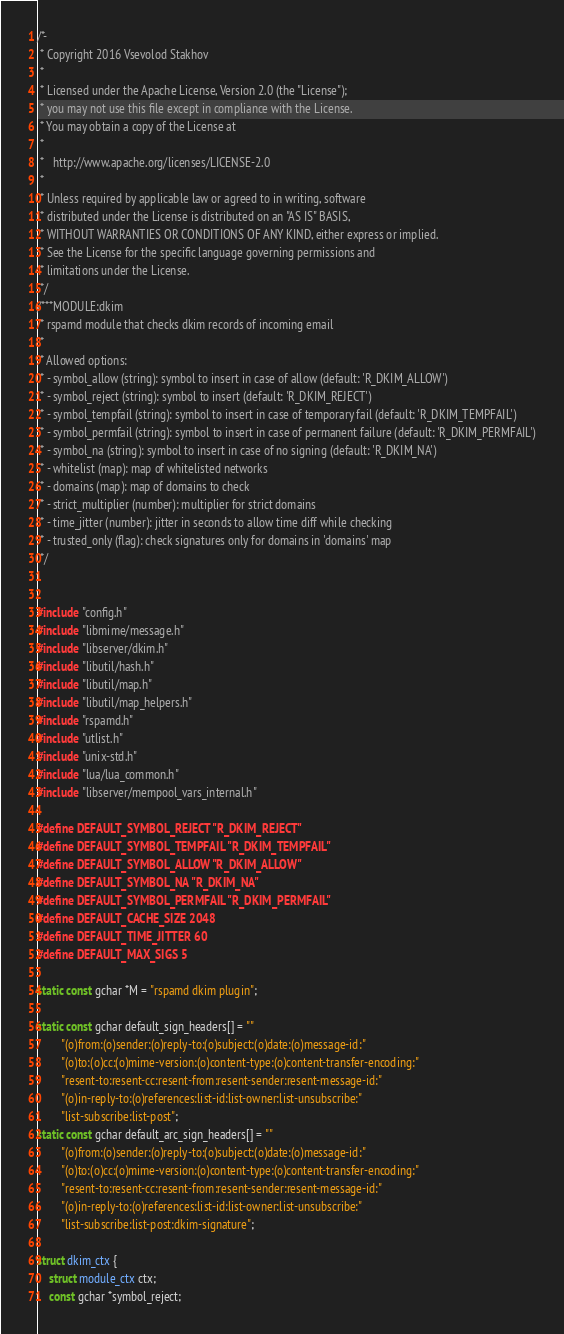<code> <loc_0><loc_0><loc_500><loc_500><_C_>/*-
 * Copyright 2016 Vsevolod Stakhov
 *
 * Licensed under the Apache License, Version 2.0 (the "License");
 * you may not use this file except in compliance with the License.
 * You may obtain a copy of the License at
 *
 *   http://www.apache.org/licenses/LICENSE-2.0
 *
 * Unless required by applicable law or agreed to in writing, software
 * distributed under the License is distributed on an "AS IS" BASIS,
 * WITHOUT WARRANTIES OR CONDITIONS OF ANY KIND, either express or implied.
 * See the License for the specific language governing permissions and
 * limitations under the License.
 */
/***MODULE:dkim
 * rspamd module that checks dkim records of incoming email
 *
 * Allowed options:
 * - symbol_allow (string): symbol to insert in case of allow (default: 'R_DKIM_ALLOW')
 * - symbol_reject (string): symbol to insert (default: 'R_DKIM_REJECT')
 * - symbol_tempfail (string): symbol to insert in case of temporary fail (default: 'R_DKIM_TEMPFAIL')
 * - symbol_permfail (string): symbol to insert in case of permanent failure (default: 'R_DKIM_PERMFAIL')
 * - symbol_na (string): symbol to insert in case of no signing (default: 'R_DKIM_NA')
 * - whitelist (map): map of whitelisted networks
 * - domains (map): map of domains to check
 * - strict_multiplier (number): multiplier for strict domains
 * - time_jitter (number): jitter in seconds to allow time diff while checking
 * - trusted_only (flag): check signatures only for domains in 'domains' map
 */


#include "config.h"
#include "libmime/message.h"
#include "libserver/dkim.h"
#include "libutil/hash.h"
#include "libutil/map.h"
#include "libutil/map_helpers.h"
#include "rspamd.h"
#include "utlist.h"
#include "unix-std.h"
#include "lua/lua_common.h"
#include "libserver/mempool_vars_internal.h"

#define DEFAULT_SYMBOL_REJECT "R_DKIM_REJECT"
#define DEFAULT_SYMBOL_TEMPFAIL "R_DKIM_TEMPFAIL"
#define DEFAULT_SYMBOL_ALLOW "R_DKIM_ALLOW"
#define DEFAULT_SYMBOL_NA "R_DKIM_NA"
#define DEFAULT_SYMBOL_PERMFAIL "R_DKIM_PERMFAIL"
#define DEFAULT_CACHE_SIZE 2048
#define DEFAULT_TIME_JITTER 60
#define DEFAULT_MAX_SIGS 5

static const gchar *M = "rspamd dkim plugin";

static const gchar default_sign_headers[] = ""
		"(o)from:(o)sender:(o)reply-to:(o)subject:(o)date:(o)message-id:"
		"(o)to:(o)cc:(o)mime-version:(o)content-type:(o)content-transfer-encoding:"
		"resent-to:resent-cc:resent-from:resent-sender:resent-message-id:"
		"(o)in-reply-to:(o)references:list-id:list-owner:list-unsubscribe:"
		"list-subscribe:list-post";
static const gchar default_arc_sign_headers[] = ""
		"(o)from:(o)sender:(o)reply-to:(o)subject:(o)date:(o)message-id:"
		"(o)to:(o)cc:(o)mime-version:(o)content-type:(o)content-transfer-encoding:"
		"resent-to:resent-cc:resent-from:resent-sender:resent-message-id:"
		"(o)in-reply-to:(o)references:list-id:list-owner:list-unsubscribe:"
		"list-subscribe:list-post:dkim-signature";

struct dkim_ctx {
	struct module_ctx ctx;
	const gchar *symbol_reject;</code> 